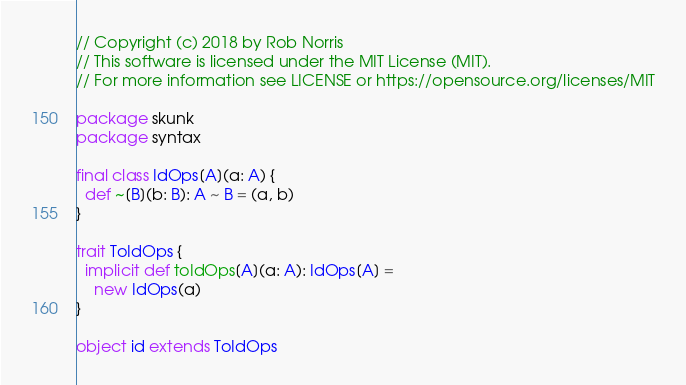Convert code to text. <code><loc_0><loc_0><loc_500><loc_500><_Scala_>// Copyright (c) 2018 by Rob Norris
// This software is licensed under the MIT License (MIT).
// For more information see LICENSE or https://opensource.org/licenses/MIT

package skunk
package syntax

final class IdOps[A](a: A) {
  def ~[B](b: B): A ~ B = (a, b)
}

trait ToIdOps {
  implicit def toIdOps[A](a: A): IdOps[A] =
    new IdOps(a)
}

object id extends ToIdOps</code> 